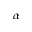<formula> <loc_0><loc_0><loc_500><loc_500>\alpha</formula> 